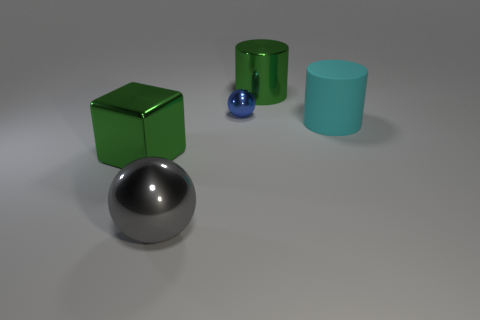Is the metal cylinder the same color as the large shiny cube?
Your response must be concise. Yes. What is the material of the cyan cylinder?
Offer a very short reply. Rubber. Does the green metal block have the same size as the gray metallic ball?
Offer a very short reply. Yes. The large cylinder that is made of the same material as the blue ball is what color?
Your answer should be very brief. Green. The large metal thing that is the same color as the big metallic cylinder is what shape?
Keep it short and to the point. Cube. Are there an equal number of large rubber things left of the tiny blue metallic object and big cyan matte objects behind the green block?
Ensure brevity in your answer.  No. There is a big green shiny thing that is behind the ball that is on the right side of the gray metal object; what is its shape?
Your answer should be compact. Cylinder. What is the material of the green thing that is the same shape as the cyan rubber object?
Provide a succinct answer. Metal. What is the color of the matte thing that is the same size as the gray metallic sphere?
Your response must be concise. Cyan. Are there an equal number of big objects on the right side of the green metal cylinder and big rubber cylinders?
Your answer should be very brief. Yes. 